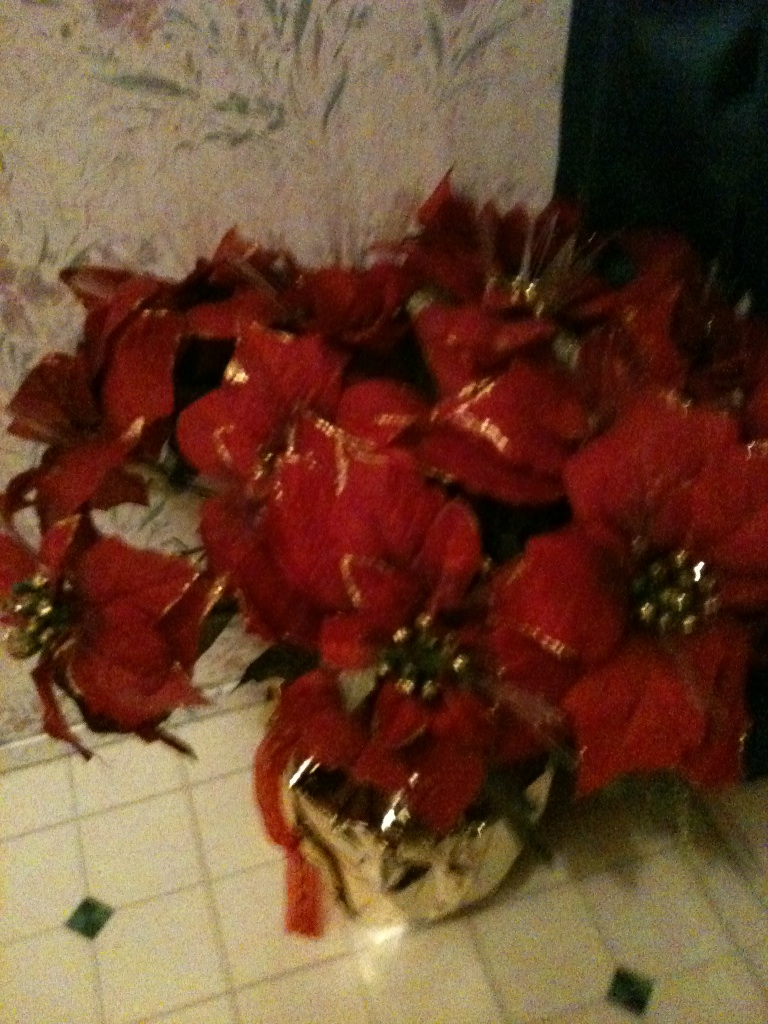Imagine if this flower arrangement had gone through many generations in a family. What stories might it hold? Describe in detail. This poinsettia arrangement, a cherished heirloom, has seen the joy and unity of many generations. Its vibrant leaves have silently witnessed countless Christmas Eves, where children, with wide-eyed wonder, gathered around to listen to grandparent tales. It has adorned tables laden with festive dinners, with its presence gracing the moments of laughter, love, and even some tears. The golden pot it rests in has been polished by the hands of family members, a ritual passed down to symbolize continuity and care. It's heard whispered promises under the mistletoe, felt the soft touch of a baby's curious hand, and seen the first steps of many a little one toddling by. Each scratch on the pot tells a story - of board games played late into the night, of surprise pets climbing atop to explore, of late-night chats by the fireplace. The poinsettia not only symbolizes festive cheer but also holds the legacy of enduring love, resilience, and shared history of a family's journey through time. 